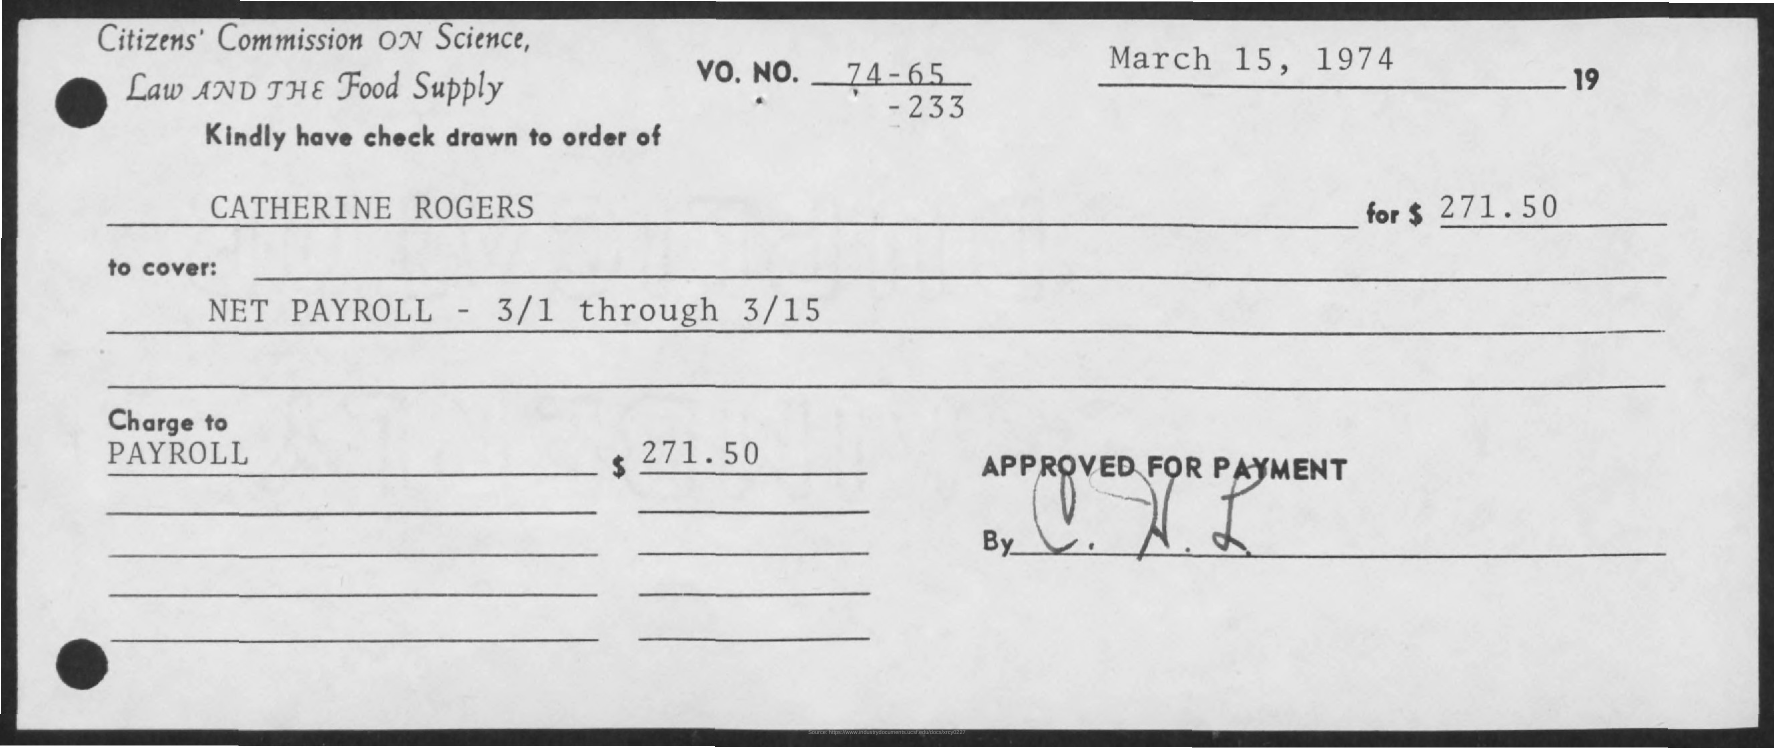What is the issued date of the check?
Provide a succinct answer. March 15, 1974. In whose name, the check is issued?
Offer a terse response. Catherine rogers. What is the amount mentioned in the check ?
Offer a terse response. $271.50. 